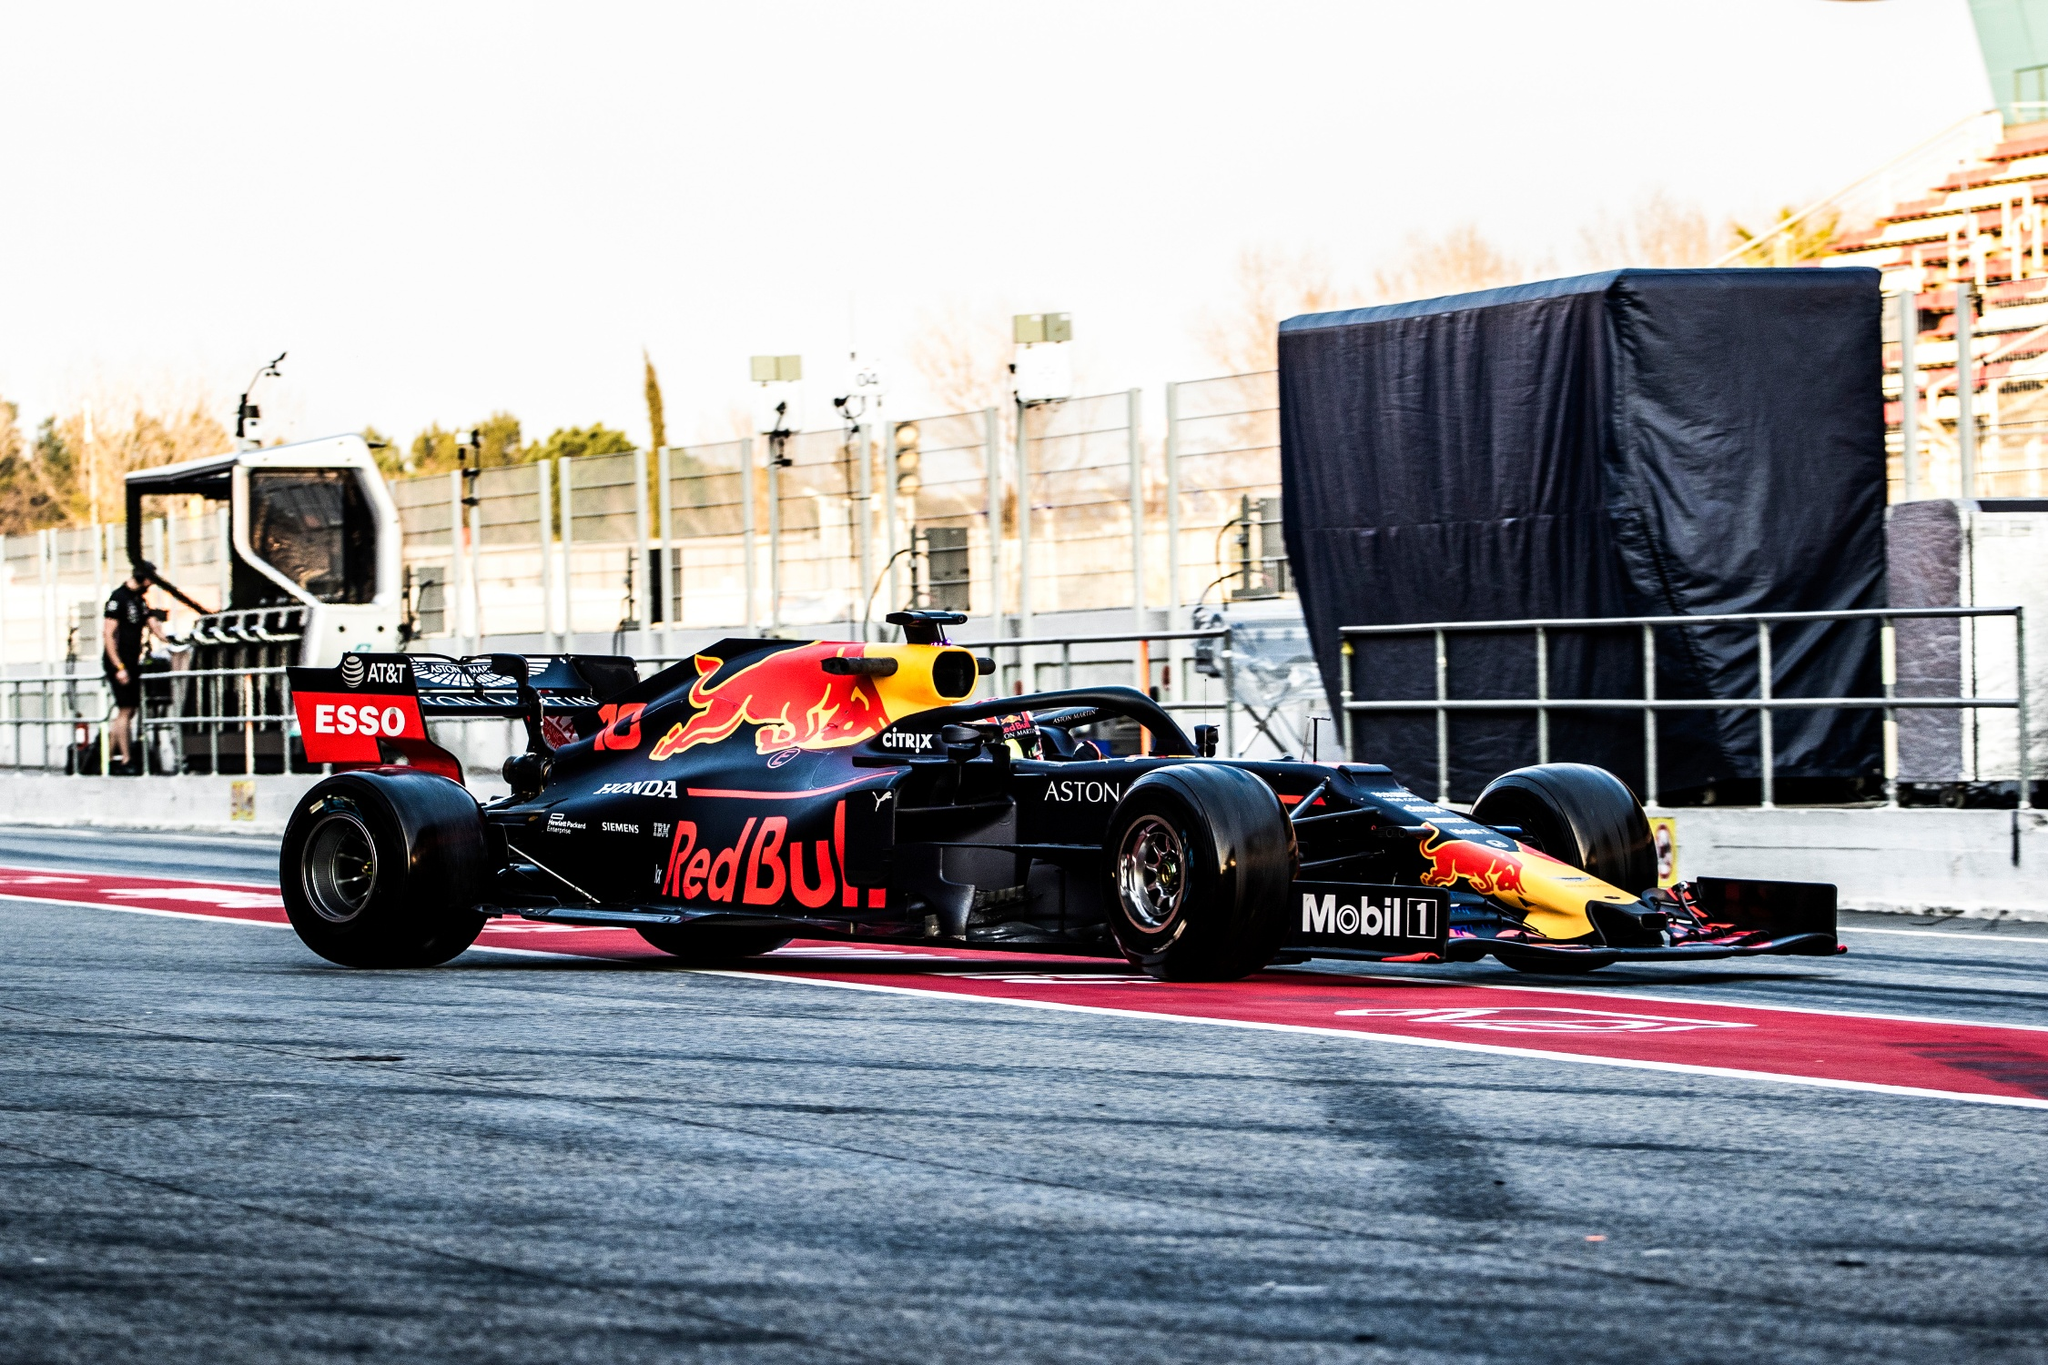Imagine the race car could speak. What might it say about its experiences on the track? If the race car could speak, it might share exhilarating tales of its experiences on the track: 'Every time I hit the asphalt, I feel the rush of adrenaline. The roaring engines, the screeching tires, and the intense competition fuel my purpose. Navigating sharp turns, accelerating on straights, and executing pit stops—each moment is a dance of precision and power. I thrive on the synergy between me and my team, knowing that every detail matters. The thrill of overtaking rivals and the sheer joy of crossing the finish line ahead of the pack are unmatched. Racing is not just a sport; it's a way of life for me.' 